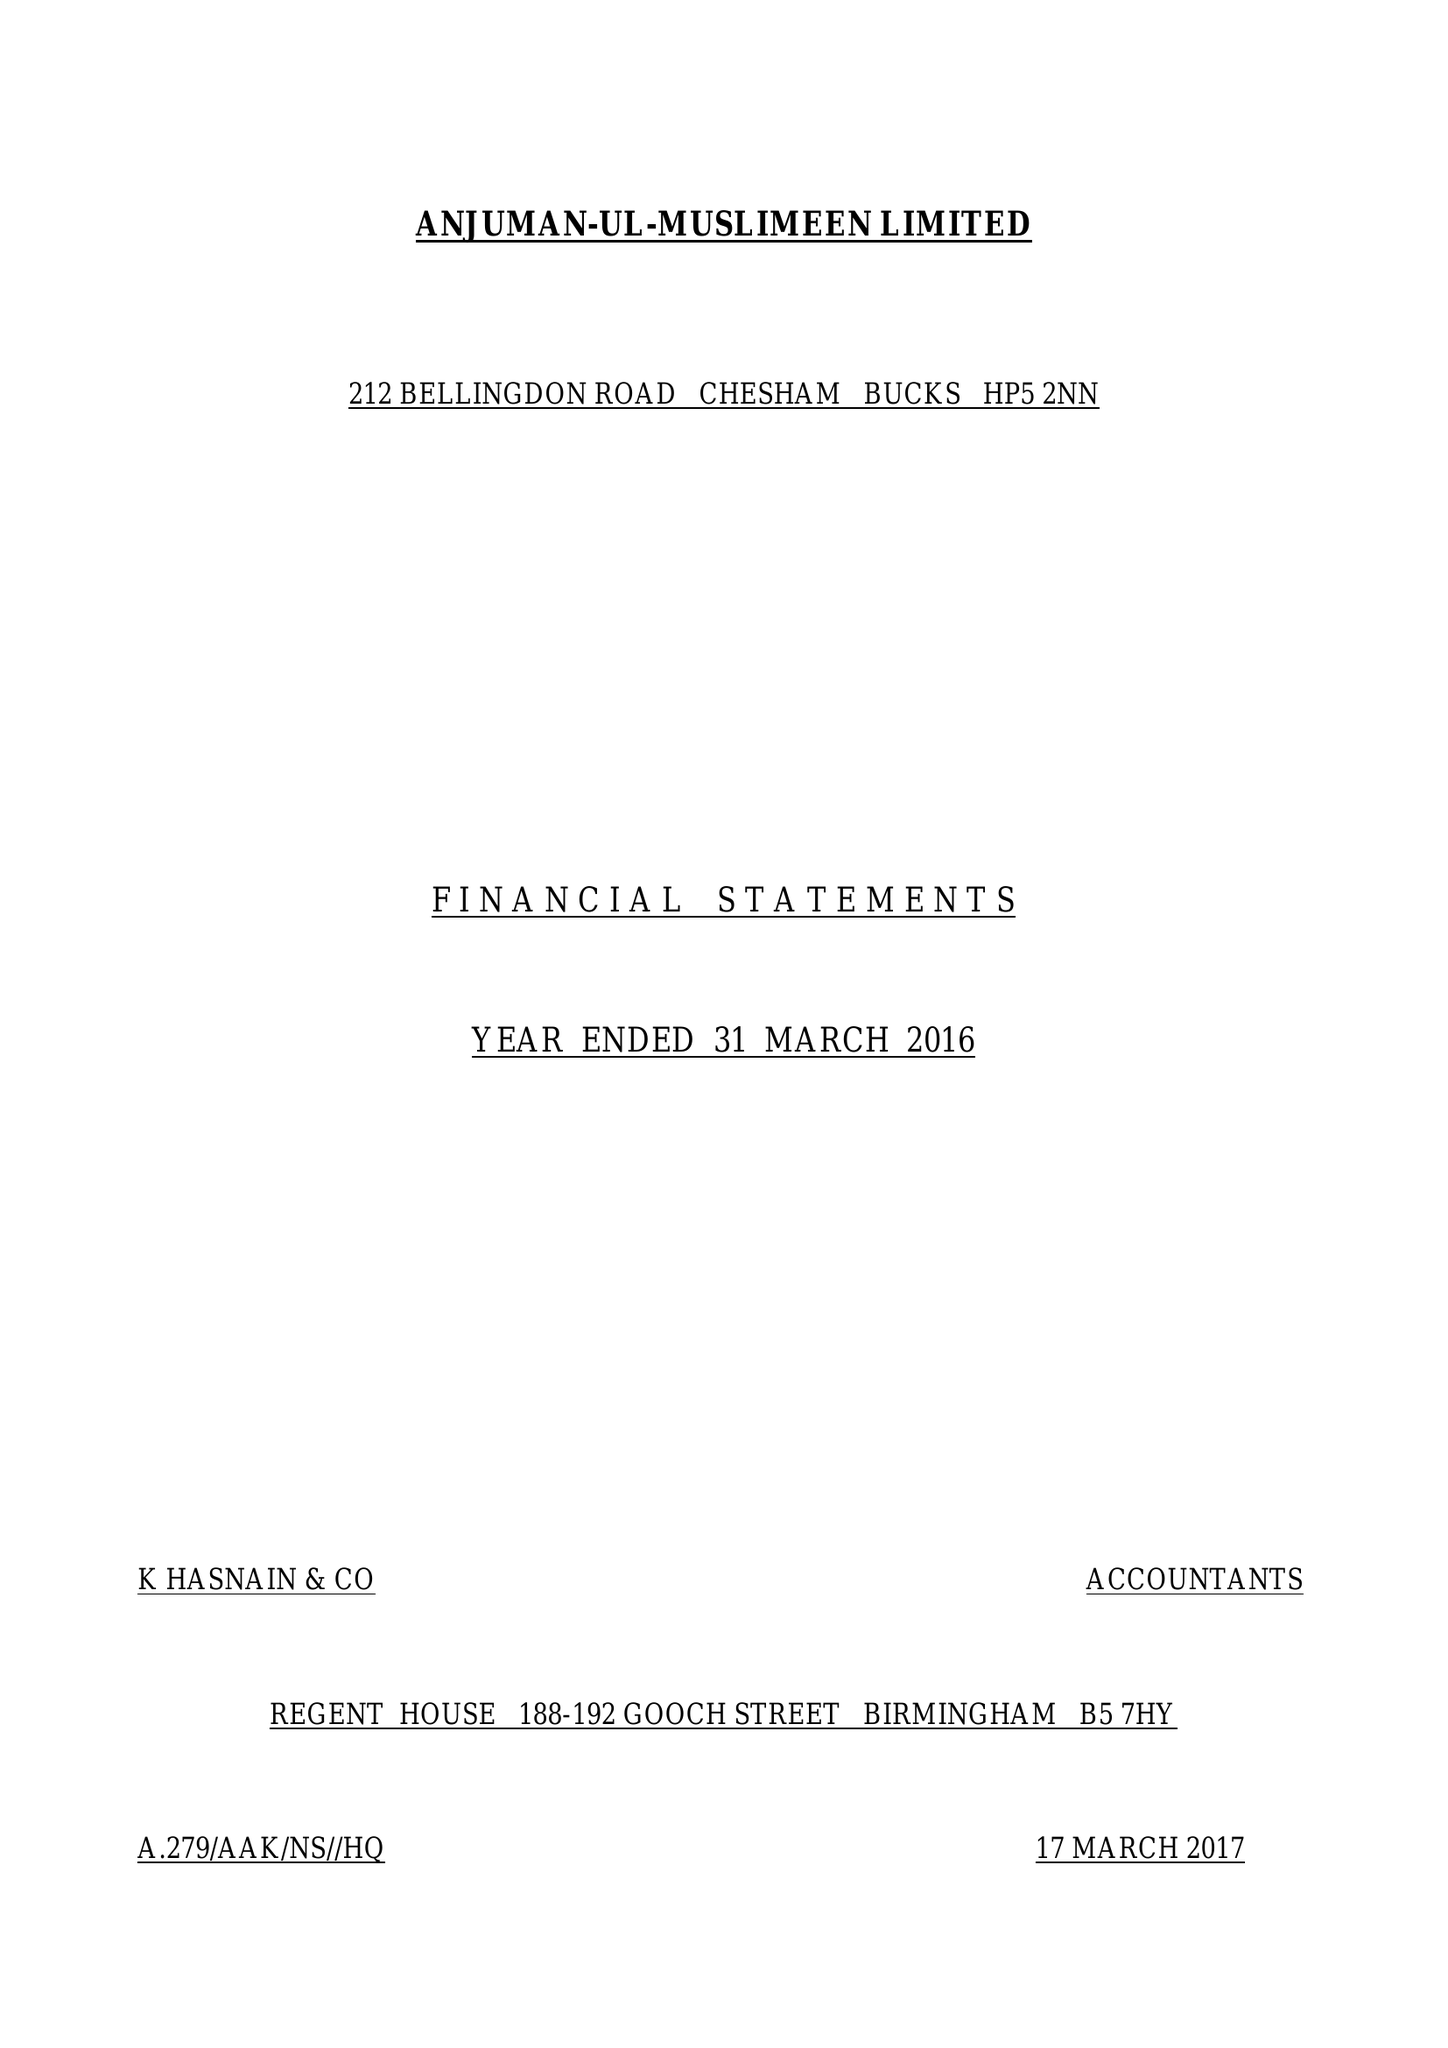What is the value for the address__street_line?
Answer the question using a single word or phrase. 345 BERKHAMPSTEAD ROAD 